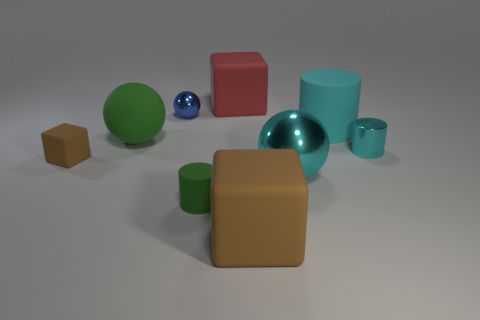What material is the green thing that is the same size as the blue metallic thing?
Provide a short and direct response. Rubber. What number of other objects are the same color as the small rubber block?
Provide a succinct answer. 1. Are there the same number of cyan metallic things that are behind the tiny metal cylinder and tiny brown things?
Your response must be concise. No. Do the cyan ball and the cyan rubber cylinder have the same size?
Your answer should be very brief. Yes. What is the tiny thing that is both on the left side of the tiny green matte thing and on the right side of the tiny block made of?
Give a very brief answer. Metal. How many other tiny rubber things are the same shape as the small cyan object?
Give a very brief answer. 1. What material is the big block that is behind the cyan rubber object?
Your response must be concise. Rubber. Is the number of big green balls right of the big green sphere less than the number of small brown matte things?
Make the answer very short. Yes. Is the large green object the same shape as the blue metallic thing?
Offer a very short reply. Yes. Is there a small rubber block?
Your response must be concise. Yes. 